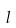Convert formula to latex. <formula><loc_0><loc_0><loc_500><loc_500>l</formula> 